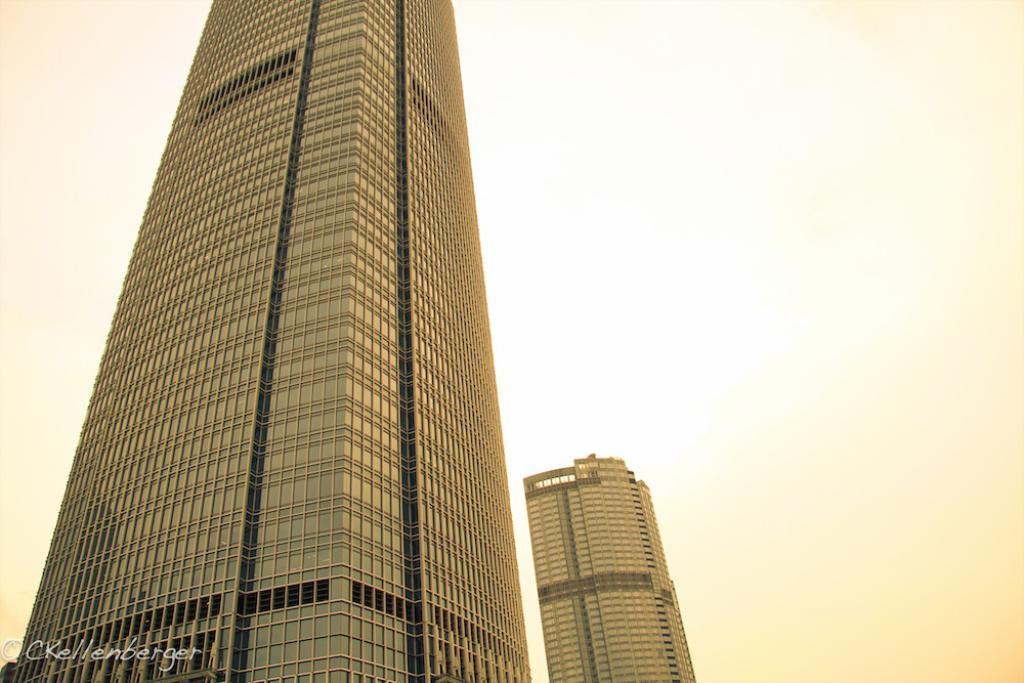How many buildings can be seen in the image? There are two buildings in the image. What is visible in the background of the image? The sky is visible in the background of the image. Can you see any spark coming from the buildings in the image? There is no spark visible in the image; it only shows two buildings and the sky. 